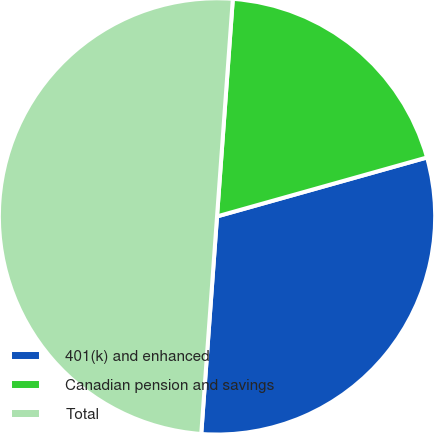Convert chart. <chart><loc_0><loc_0><loc_500><loc_500><pie_chart><fcel>401(k) and enhanced<fcel>Canadian pension and savings<fcel>Total<nl><fcel>30.51%<fcel>19.49%<fcel>50.0%<nl></chart> 